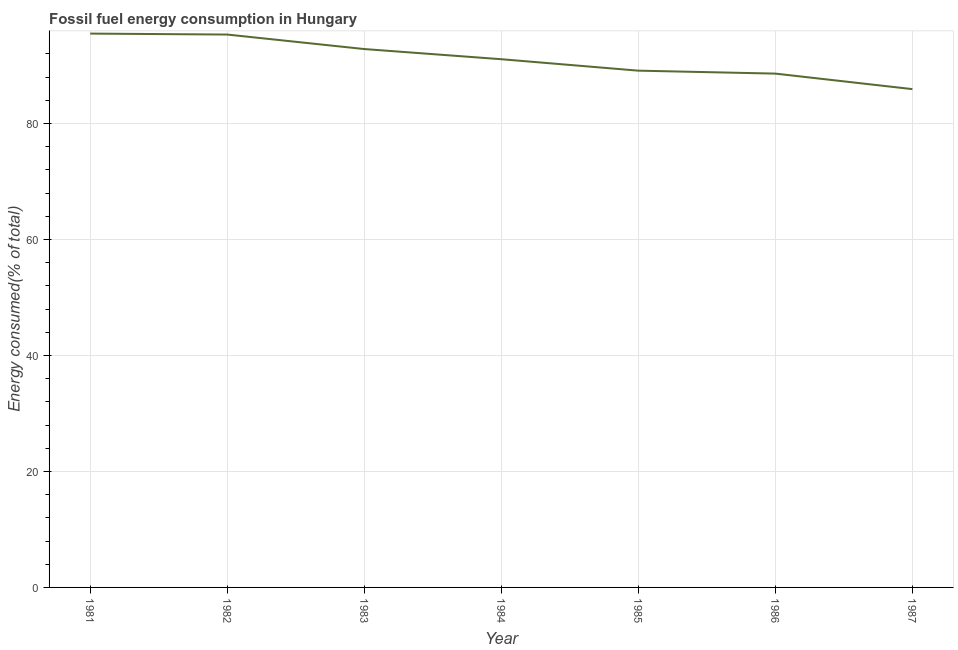What is the fossil fuel energy consumption in 1986?
Your response must be concise. 88.6. Across all years, what is the maximum fossil fuel energy consumption?
Your answer should be very brief. 95.5. Across all years, what is the minimum fossil fuel energy consumption?
Give a very brief answer. 85.93. What is the sum of the fossil fuel energy consumption?
Offer a very short reply. 638.41. What is the difference between the fossil fuel energy consumption in 1981 and 1982?
Your answer should be compact. 0.16. What is the average fossil fuel energy consumption per year?
Provide a short and direct response. 91.2. What is the median fossil fuel energy consumption?
Give a very brief answer. 91.09. Do a majority of the years between 1981 and 1984 (inclusive) have fossil fuel energy consumption greater than 12 %?
Your answer should be compact. Yes. What is the ratio of the fossil fuel energy consumption in 1985 to that in 1986?
Keep it short and to the point. 1.01. Is the fossil fuel energy consumption in 1982 less than that in 1985?
Your answer should be very brief. No. Is the difference between the fossil fuel energy consumption in 1983 and 1986 greater than the difference between any two years?
Your answer should be very brief. No. What is the difference between the highest and the second highest fossil fuel energy consumption?
Offer a very short reply. 0.16. Is the sum of the fossil fuel energy consumption in 1981 and 1982 greater than the maximum fossil fuel energy consumption across all years?
Provide a succinct answer. Yes. What is the difference between the highest and the lowest fossil fuel energy consumption?
Your answer should be compact. 9.57. In how many years, is the fossil fuel energy consumption greater than the average fossil fuel energy consumption taken over all years?
Your answer should be very brief. 3. How many lines are there?
Give a very brief answer. 1. What is the difference between two consecutive major ticks on the Y-axis?
Offer a terse response. 20. Are the values on the major ticks of Y-axis written in scientific E-notation?
Make the answer very short. No. Does the graph contain any zero values?
Your answer should be compact. No. Does the graph contain grids?
Give a very brief answer. Yes. What is the title of the graph?
Provide a short and direct response. Fossil fuel energy consumption in Hungary. What is the label or title of the Y-axis?
Provide a short and direct response. Energy consumed(% of total). What is the Energy consumed(% of total) in 1981?
Ensure brevity in your answer.  95.5. What is the Energy consumed(% of total) in 1982?
Your answer should be very brief. 95.34. What is the Energy consumed(% of total) in 1983?
Keep it short and to the point. 92.84. What is the Energy consumed(% of total) in 1984?
Your answer should be very brief. 91.09. What is the Energy consumed(% of total) of 1985?
Provide a succinct answer. 89.11. What is the Energy consumed(% of total) in 1986?
Your response must be concise. 88.6. What is the Energy consumed(% of total) in 1987?
Offer a terse response. 85.93. What is the difference between the Energy consumed(% of total) in 1981 and 1982?
Your answer should be compact. 0.16. What is the difference between the Energy consumed(% of total) in 1981 and 1983?
Your answer should be very brief. 2.66. What is the difference between the Energy consumed(% of total) in 1981 and 1984?
Make the answer very short. 4.42. What is the difference between the Energy consumed(% of total) in 1981 and 1985?
Offer a very short reply. 6.39. What is the difference between the Energy consumed(% of total) in 1981 and 1986?
Provide a succinct answer. 6.9. What is the difference between the Energy consumed(% of total) in 1981 and 1987?
Your answer should be compact. 9.57. What is the difference between the Energy consumed(% of total) in 1982 and 1983?
Offer a terse response. 2.5. What is the difference between the Energy consumed(% of total) in 1982 and 1984?
Give a very brief answer. 4.25. What is the difference between the Energy consumed(% of total) in 1982 and 1985?
Ensure brevity in your answer.  6.23. What is the difference between the Energy consumed(% of total) in 1982 and 1986?
Offer a terse response. 6.73. What is the difference between the Energy consumed(% of total) in 1982 and 1987?
Offer a very short reply. 9.41. What is the difference between the Energy consumed(% of total) in 1983 and 1984?
Your response must be concise. 1.75. What is the difference between the Energy consumed(% of total) in 1983 and 1985?
Make the answer very short. 3.73. What is the difference between the Energy consumed(% of total) in 1983 and 1986?
Your response must be concise. 4.23. What is the difference between the Energy consumed(% of total) in 1983 and 1987?
Offer a terse response. 6.91. What is the difference between the Energy consumed(% of total) in 1984 and 1985?
Your answer should be very brief. 1.97. What is the difference between the Energy consumed(% of total) in 1984 and 1986?
Your answer should be very brief. 2.48. What is the difference between the Energy consumed(% of total) in 1984 and 1987?
Your response must be concise. 5.16. What is the difference between the Energy consumed(% of total) in 1985 and 1986?
Your answer should be very brief. 0.51. What is the difference between the Energy consumed(% of total) in 1985 and 1987?
Your answer should be compact. 3.18. What is the difference between the Energy consumed(% of total) in 1986 and 1987?
Your answer should be compact. 2.68. What is the ratio of the Energy consumed(% of total) in 1981 to that in 1983?
Keep it short and to the point. 1.03. What is the ratio of the Energy consumed(% of total) in 1981 to that in 1984?
Ensure brevity in your answer.  1.05. What is the ratio of the Energy consumed(% of total) in 1981 to that in 1985?
Ensure brevity in your answer.  1.07. What is the ratio of the Energy consumed(% of total) in 1981 to that in 1986?
Provide a short and direct response. 1.08. What is the ratio of the Energy consumed(% of total) in 1981 to that in 1987?
Your response must be concise. 1.11. What is the ratio of the Energy consumed(% of total) in 1982 to that in 1984?
Your answer should be compact. 1.05. What is the ratio of the Energy consumed(% of total) in 1982 to that in 1985?
Make the answer very short. 1.07. What is the ratio of the Energy consumed(% of total) in 1982 to that in 1986?
Offer a terse response. 1.08. What is the ratio of the Energy consumed(% of total) in 1982 to that in 1987?
Your answer should be compact. 1.11. What is the ratio of the Energy consumed(% of total) in 1983 to that in 1984?
Make the answer very short. 1.02. What is the ratio of the Energy consumed(% of total) in 1983 to that in 1985?
Your answer should be very brief. 1.04. What is the ratio of the Energy consumed(% of total) in 1983 to that in 1986?
Provide a short and direct response. 1.05. What is the ratio of the Energy consumed(% of total) in 1984 to that in 1985?
Your answer should be compact. 1.02. What is the ratio of the Energy consumed(% of total) in 1984 to that in 1986?
Give a very brief answer. 1.03. What is the ratio of the Energy consumed(% of total) in 1984 to that in 1987?
Your response must be concise. 1.06. What is the ratio of the Energy consumed(% of total) in 1986 to that in 1987?
Offer a very short reply. 1.03. 